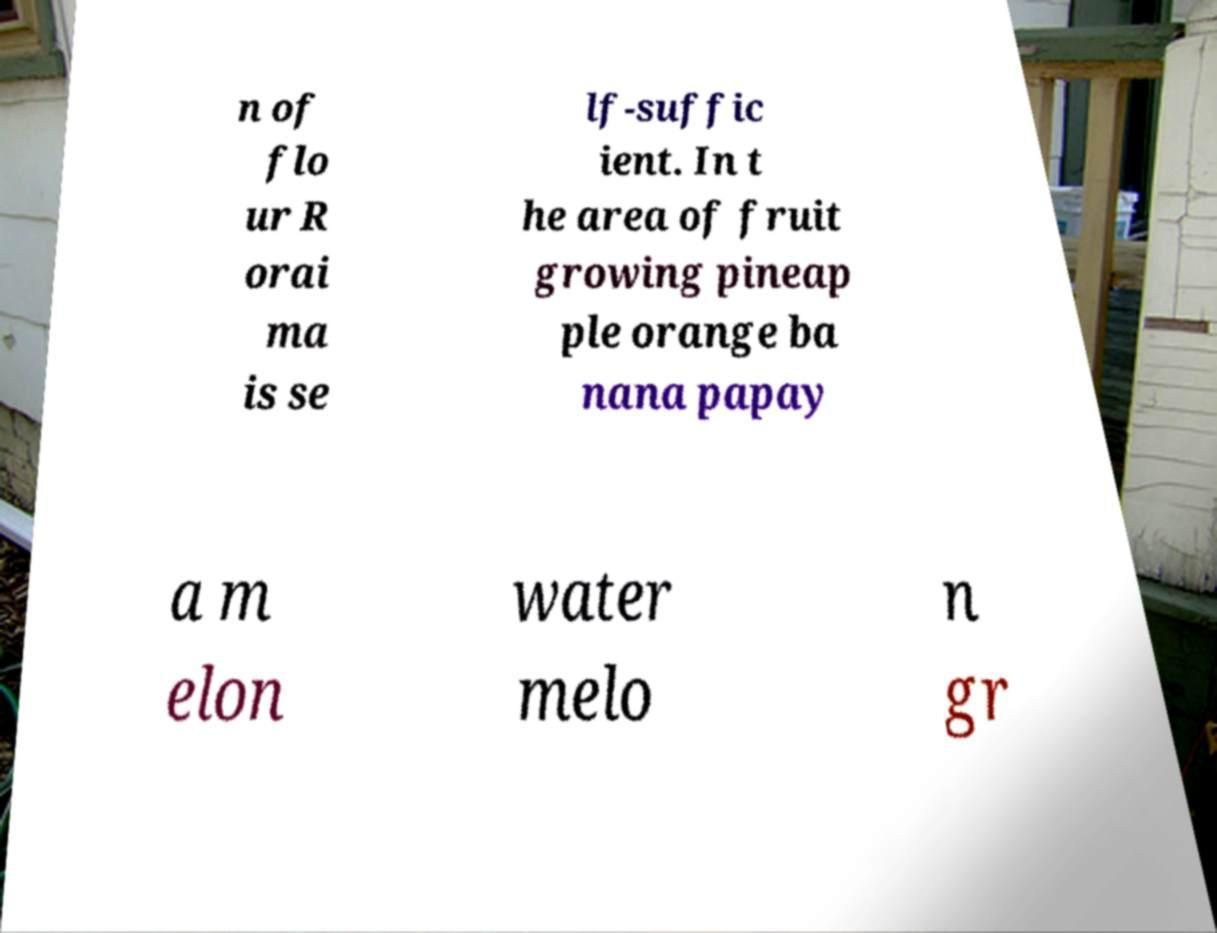Can you accurately transcribe the text from the provided image for me? n of flo ur R orai ma is se lf-suffic ient. In t he area of fruit growing pineap ple orange ba nana papay a m elon water melo n gr 